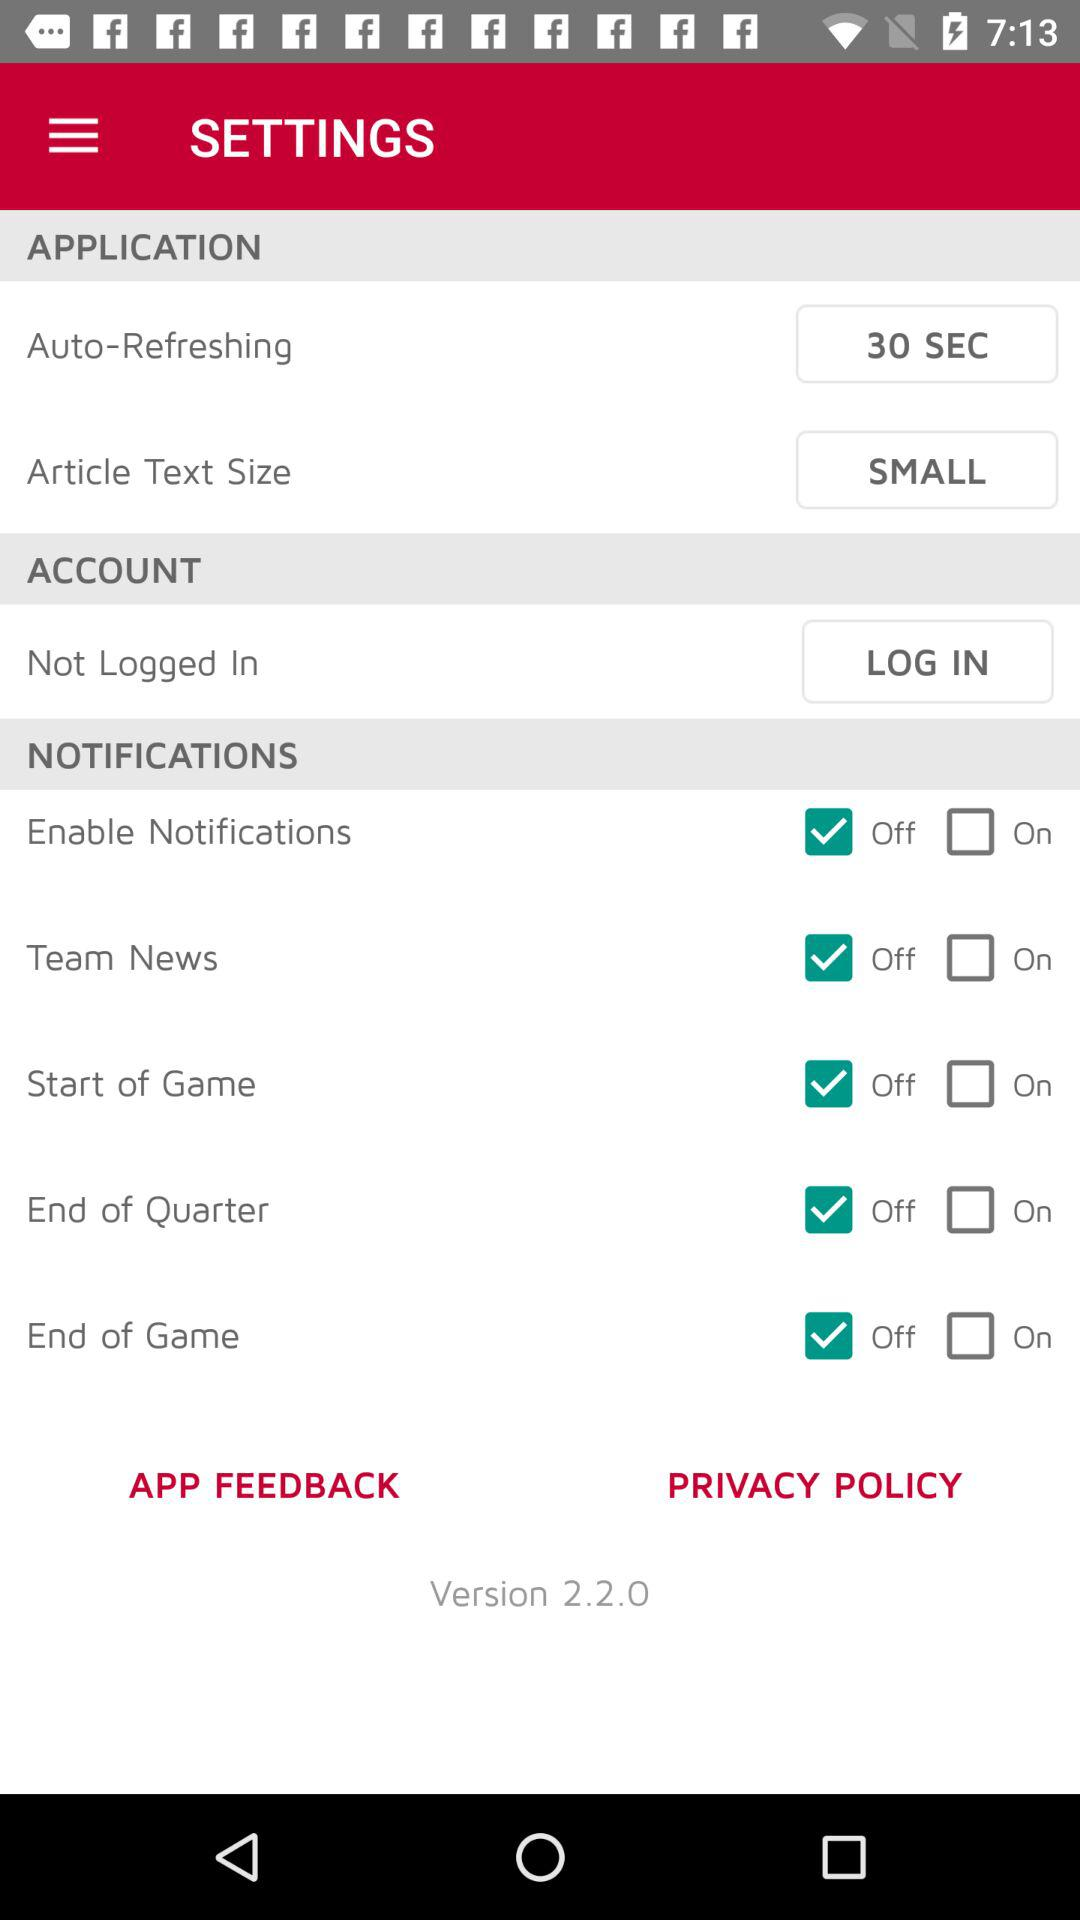Which text size is selected in the "Article Text Size"? The selected text size is small. 